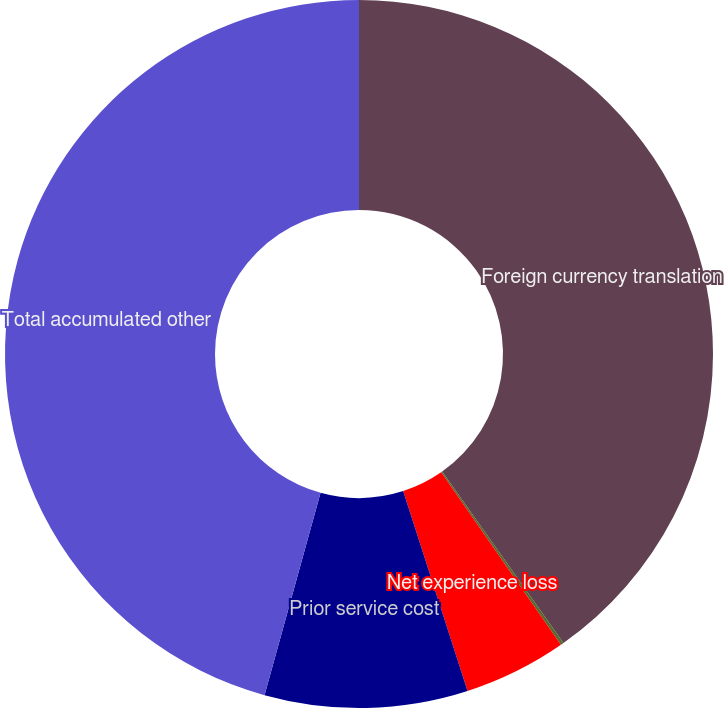Convert chart. <chart><loc_0><loc_0><loc_500><loc_500><pie_chart><fcel>Foreign currency translation<fcel>Cash flow hedges - unrealized<fcel>Net experience loss<fcel>Prior service cost<fcel>Total accumulated other<nl><fcel>40.2%<fcel>0.14%<fcel>4.7%<fcel>9.26%<fcel>45.7%<nl></chart> 